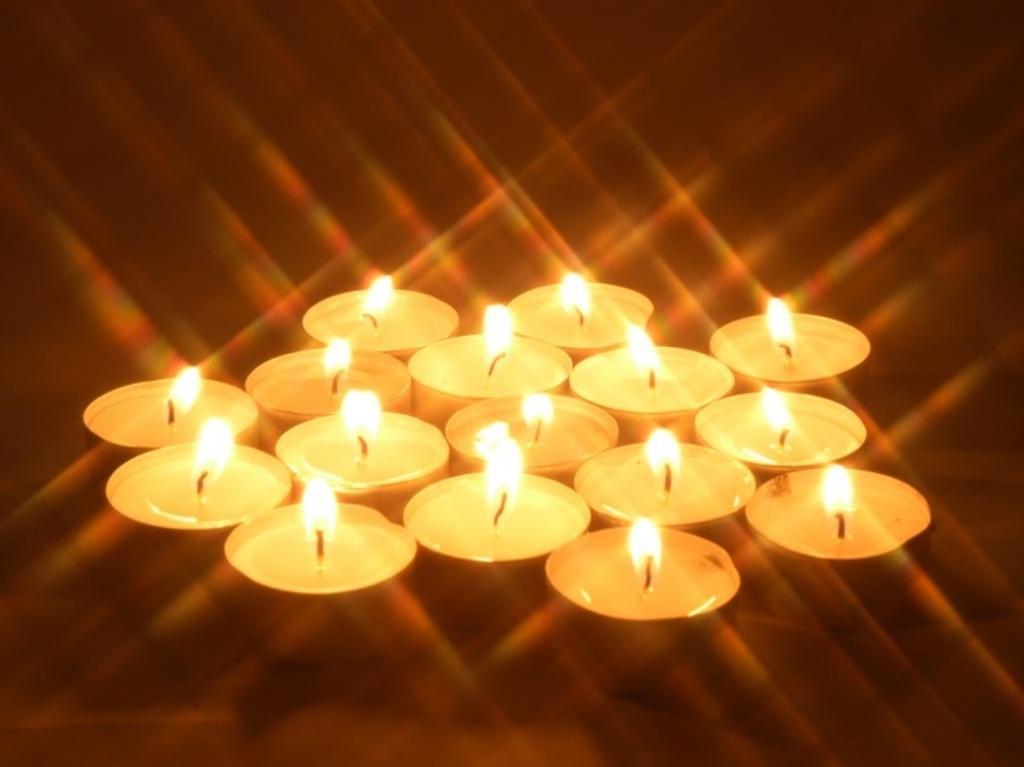Describe this image in one or two sentences. In this image we can see tea light candles with flames. 